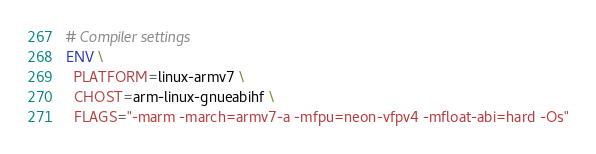Convert code to text. <code><loc_0><loc_0><loc_500><loc_500><_Dockerfile_># Compiler settings
ENV \
  PLATFORM=linux-armv7 \
  CHOST=arm-linux-gnueabihf \
  FLAGS="-marm -march=armv7-a -mfpu=neon-vfpv4 -mfloat-abi=hard -Os"
</code> 